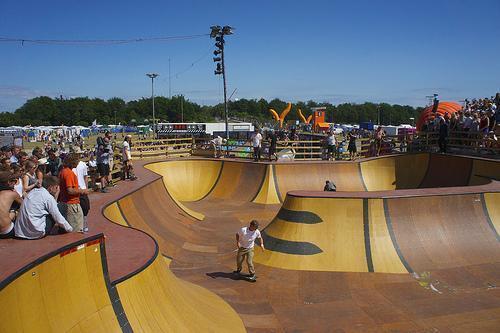How many people are wearing an orange shirt?
Give a very brief answer. 1. 